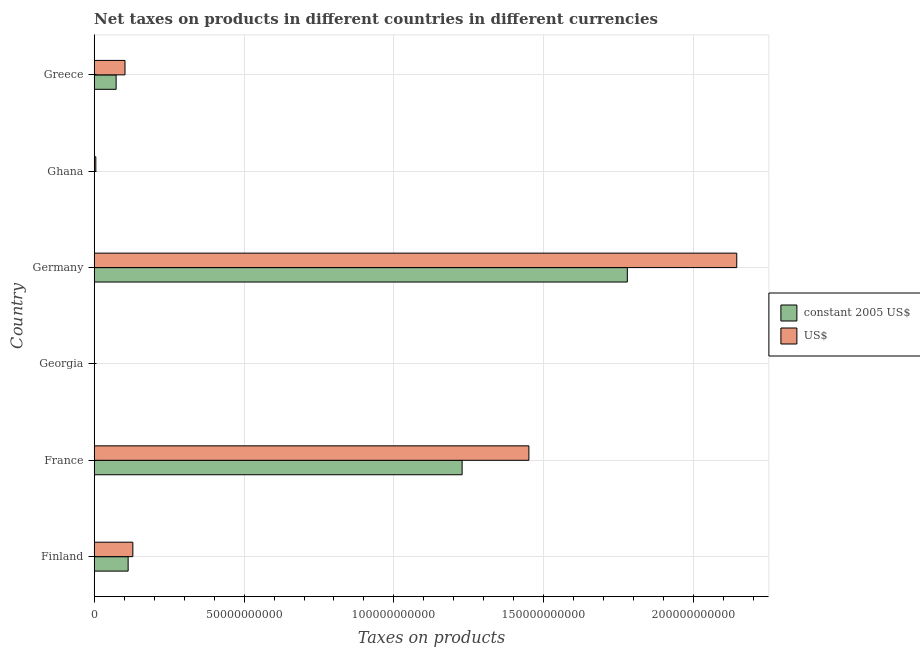How many groups of bars are there?
Offer a very short reply. 6. Are the number of bars per tick equal to the number of legend labels?
Keep it short and to the point. Yes. Are the number of bars on each tick of the Y-axis equal?
Give a very brief answer. Yes. How many bars are there on the 3rd tick from the bottom?
Provide a short and direct response. 2. What is the label of the 5th group of bars from the top?
Give a very brief answer. France. In how many cases, is the number of bars for a given country not equal to the number of legend labels?
Offer a very short reply. 0. What is the net taxes in us$ in Greece?
Your answer should be very brief. 1.03e+1. Across all countries, what is the maximum net taxes in us$?
Give a very brief answer. 2.14e+11. Across all countries, what is the minimum net taxes in us$?
Your answer should be compact. 5.30e+07. In which country was the net taxes in constant 2005 us$ minimum?
Give a very brief answer. Georgia. What is the total net taxes in us$ in the graph?
Your response must be concise. 3.83e+11. What is the difference between the net taxes in us$ in Ghana and that in Greece?
Keep it short and to the point. -9.73e+09. What is the difference between the net taxes in constant 2005 us$ in Finland and the net taxes in us$ in France?
Provide a short and direct response. -1.34e+11. What is the average net taxes in constant 2005 us$ per country?
Offer a terse response. 5.32e+1. What is the difference between the net taxes in us$ and net taxes in constant 2005 us$ in Germany?
Keep it short and to the point. 3.65e+1. What is the ratio of the net taxes in constant 2005 us$ in Finland to that in France?
Give a very brief answer. 0.09. Is the difference between the net taxes in constant 2005 us$ in Georgia and Greece greater than the difference between the net taxes in us$ in Georgia and Greece?
Keep it short and to the point. Yes. What is the difference between the highest and the second highest net taxes in us$?
Offer a terse response. 6.94e+1. What is the difference between the highest and the lowest net taxes in constant 2005 us$?
Give a very brief answer. 1.78e+11. What does the 1st bar from the top in France represents?
Your answer should be compact. US$. What does the 2nd bar from the bottom in Georgia represents?
Keep it short and to the point. US$. How many bars are there?
Your response must be concise. 12. Are the values on the major ticks of X-axis written in scientific E-notation?
Your answer should be compact. No. Does the graph contain grids?
Provide a succinct answer. Yes. Where does the legend appear in the graph?
Keep it short and to the point. Center right. How many legend labels are there?
Your response must be concise. 2. What is the title of the graph?
Keep it short and to the point. Net taxes on products in different countries in different currencies. Does "Foreign Liabilities" appear as one of the legend labels in the graph?
Keep it short and to the point. No. What is the label or title of the X-axis?
Your answer should be very brief. Taxes on products. What is the Taxes on products of constant 2005 US$ in Finland?
Keep it short and to the point. 1.13e+1. What is the Taxes on products of US$ in Finland?
Provide a short and direct response. 1.29e+1. What is the Taxes on products in constant 2005 US$ in France?
Offer a very short reply. 1.23e+11. What is the Taxes on products in US$ in France?
Provide a succinct answer. 1.45e+11. What is the Taxes on products of constant 2005 US$ in Georgia?
Make the answer very short. 1.90e+07. What is the Taxes on products in US$ in Georgia?
Give a very brief answer. 5.30e+07. What is the Taxes on products in constant 2005 US$ in Germany?
Give a very brief answer. 1.78e+11. What is the Taxes on products of US$ in Germany?
Your response must be concise. 2.14e+11. What is the Taxes on products in constant 2005 US$ in Ghana?
Give a very brief answer. 5.19e+07. What is the Taxes on products of US$ in Ghana?
Provide a succinct answer. 5.43e+08. What is the Taxes on products in constant 2005 US$ in Greece?
Your response must be concise. 7.32e+09. What is the Taxes on products of US$ in Greece?
Your response must be concise. 1.03e+1. Across all countries, what is the maximum Taxes on products in constant 2005 US$?
Make the answer very short. 1.78e+11. Across all countries, what is the maximum Taxes on products of US$?
Keep it short and to the point. 2.14e+11. Across all countries, what is the minimum Taxes on products in constant 2005 US$?
Make the answer very short. 1.90e+07. Across all countries, what is the minimum Taxes on products in US$?
Your answer should be compact. 5.30e+07. What is the total Taxes on products in constant 2005 US$ in the graph?
Provide a short and direct response. 3.19e+11. What is the total Taxes on products in US$ in the graph?
Give a very brief answer. 3.83e+11. What is the difference between the Taxes on products of constant 2005 US$ in Finland and that in France?
Offer a very short reply. -1.11e+11. What is the difference between the Taxes on products in US$ in Finland and that in France?
Provide a short and direct response. -1.32e+11. What is the difference between the Taxes on products in constant 2005 US$ in Finland and that in Georgia?
Make the answer very short. 1.13e+1. What is the difference between the Taxes on products of US$ in Finland and that in Georgia?
Your answer should be compact. 1.28e+1. What is the difference between the Taxes on products in constant 2005 US$ in Finland and that in Germany?
Offer a very short reply. -1.67e+11. What is the difference between the Taxes on products of US$ in Finland and that in Germany?
Make the answer very short. -2.01e+11. What is the difference between the Taxes on products of constant 2005 US$ in Finland and that in Ghana?
Make the answer very short. 1.13e+1. What is the difference between the Taxes on products in US$ in Finland and that in Ghana?
Provide a succinct answer. 1.23e+1. What is the difference between the Taxes on products in constant 2005 US$ in Finland and that in Greece?
Provide a short and direct response. 4.01e+09. What is the difference between the Taxes on products of US$ in Finland and that in Greece?
Ensure brevity in your answer.  2.62e+09. What is the difference between the Taxes on products of constant 2005 US$ in France and that in Georgia?
Provide a short and direct response. 1.23e+11. What is the difference between the Taxes on products of US$ in France and that in Georgia?
Offer a terse response. 1.45e+11. What is the difference between the Taxes on products of constant 2005 US$ in France and that in Germany?
Offer a terse response. -5.51e+1. What is the difference between the Taxes on products of US$ in France and that in Germany?
Offer a terse response. -6.94e+1. What is the difference between the Taxes on products of constant 2005 US$ in France and that in Ghana?
Your answer should be very brief. 1.23e+11. What is the difference between the Taxes on products in US$ in France and that in Ghana?
Your response must be concise. 1.44e+11. What is the difference between the Taxes on products of constant 2005 US$ in France and that in Greece?
Your answer should be very brief. 1.15e+11. What is the difference between the Taxes on products in US$ in France and that in Greece?
Your answer should be compact. 1.35e+11. What is the difference between the Taxes on products of constant 2005 US$ in Georgia and that in Germany?
Provide a short and direct response. -1.78e+11. What is the difference between the Taxes on products of US$ in Georgia and that in Germany?
Provide a short and direct response. -2.14e+11. What is the difference between the Taxes on products of constant 2005 US$ in Georgia and that in Ghana?
Keep it short and to the point. -3.29e+07. What is the difference between the Taxes on products in US$ in Georgia and that in Ghana?
Offer a very short reply. -4.90e+08. What is the difference between the Taxes on products of constant 2005 US$ in Georgia and that in Greece?
Ensure brevity in your answer.  -7.30e+09. What is the difference between the Taxes on products of US$ in Georgia and that in Greece?
Offer a very short reply. -1.02e+1. What is the difference between the Taxes on products of constant 2005 US$ in Germany and that in Ghana?
Provide a succinct answer. 1.78e+11. What is the difference between the Taxes on products of US$ in Germany and that in Ghana?
Your answer should be compact. 2.14e+11. What is the difference between the Taxes on products in constant 2005 US$ in Germany and that in Greece?
Make the answer very short. 1.71e+11. What is the difference between the Taxes on products in US$ in Germany and that in Greece?
Make the answer very short. 2.04e+11. What is the difference between the Taxes on products in constant 2005 US$ in Ghana and that in Greece?
Ensure brevity in your answer.  -7.27e+09. What is the difference between the Taxes on products of US$ in Ghana and that in Greece?
Provide a short and direct response. -9.73e+09. What is the difference between the Taxes on products of constant 2005 US$ in Finland and the Taxes on products of US$ in France?
Make the answer very short. -1.34e+11. What is the difference between the Taxes on products of constant 2005 US$ in Finland and the Taxes on products of US$ in Georgia?
Provide a succinct answer. 1.13e+1. What is the difference between the Taxes on products in constant 2005 US$ in Finland and the Taxes on products in US$ in Germany?
Your answer should be compact. -2.03e+11. What is the difference between the Taxes on products in constant 2005 US$ in Finland and the Taxes on products in US$ in Ghana?
Your answer should be compact. 1.08e+1. What is the difference between the Taxes on products of constant 2005 US$ in Finland and the Taxes on products of US$ in Greece?
Your response must be concise. 1.05e+09. What is the difference between the Taxes on products in constant 2005 US$ in France and the Taxes on products in US$ in Georgia?
Make the answer very short. 1.23e+11. What is the difference between the Taxes on products in constant 2005 US$ in France and the Taxes on products in US$ in Germany?
Provide a short and direct response. -9.16e+1. What is the difference between the Taxes on products of constant 2005 US$ in France and the Taxes on products of US$ in Ghana?
Provide a succinct answer. 1.22e+11. What is the difference between the Taxes on products in constant 2005 US$ in France and the Taxes on products in US$ in Greece?
Your answer should be compact. 1.12e+11. What is the difference between the Taxes on products of constant 2005 US$ in Georgia and the Taxes on products of US$ in Germany?
Your answer should be compact. -2.14e+11. What is the difference between the Taxes on products in constant 2005 US$ in Georgia and the Taxes on products in US$ in Ghana?
Provide a short and direct response. -5.24e+08. What is the difference between the Taxes on products in constant 2005 US$ in Georgia and the Taxes on products in US$ in Greece?
Ensure brevity in your answer.  -1.03e+1. What is the difference between the Taxes on products of constant 2005 US$ in Germany and the Taxes on products of US$ in Ghana?
Ensure brevity in your answer.  1.77e+11. What is the difference between the Taxes on products in constant 2005 US$ in Germany and the Taxes on products in US$ in Greece?
Offer a terse response. 1.68e+11. What is the difference between the Taxes on products in constant 2005 US$ in Ghana and the Taxes on products in US$ in Greece?
Provide a succinct answer. -1.02e+1. What is the average Taxes on products of constant 2005 US$ per country?
Offer a terse response. 5.32e+1. What is the average Taxes on products in US$ per country?
Provide a succinct answer. 6.39e+1. What is the difference between the Taxes on products in constant 2005 US$ and Taxes on products in US$ in Finland?
Ensure brevity in your answer.  -1.57e+09. What is the difference between the Taxes on products in constant 2005 US$ and Taxes on products in US$ in France?
Provide a succinct answer. -2.23e+1. What is the difference between the Taxes on products in constant 2005 US$ and Taxes on products in US$ in Georgia?
Make the answer very short. -3.40e+07. What is the difference between the Taxes on products of constant 2005 US$ and Taxes on products of US$ in Germany?
Your response must be concise. -3.65e+1. What is the difference between the Taxes on products in constant 2005 US$ and Taxes on products in US$ in Ghana?
Your answer should be compact. -4.91e+08. What is the difference between the Taxes on products in constant 2005 US$ and Taxes on products in US$ in Greece?
Your answer should be very brief. -2.96e+09. What is the ratio of the Taxes on products of constant 2005 US$ in Finland to that in France?
Give a very brief answer. 0.09. What is the ratio of the Taxes on products in US$ in Finland to that in France?
Your answer should be very brief. 0.09. What is the ratio of the Taxes on products in constant 2005 US$ in Finland to that in Georgia?
Provide a short and direct response. 595.24. What is the ratio of the Taxes on products of US$ in Finland to that in Georgia?
Offer a very short reply. 243.2. What is the ratio of the Taxes on products in constant 2005 US$ in Finland to that in Germany?
Provide a short and direct response. 0.06. What is the ratio of the Taxes on products in US$ in Finland to that in Germany?
Your response must be concise. 0.06. What is the ratio of the Taxes on products in constant 2005 US$ in Finland to that in Ghana?
Provide a succinct answer. 218.14. What is the ratio of the Taxes on products in US$ in Finland to that in Ghana?
Provide a short and direct response. 23.74. What is the ratio of the Taxes on products in constant 2005 US$ in Finland to that in Greece?
Ensure brevity in your answer.  1.55. What is the ratio of the Taxes on products in US$ in Finland to that in Greece?
Your response must be concise. 1.25. What is the ratio of the Taxes on products of constant 2005 US$ in France to that in Georgia?
Your response must be concise. 6451.63. What is the ratio of the Taxes on products of US$ in France to that in Georgia?
Your answer should be compact. 2735.91. What is the ratio of the Taxes on products of constant 2005 US$ in France to that in Germany?
Give a very brief answer. 0.69. What is the ratio of the Taxes on products of US$ in France to that in Germany?
Your response must be concise. 0.68. What is the ratio of the Taxes on products in constant 2005 US$ in France to that in Ghana?
Your answer should be very brief. 2364.39. What is the ratio of the Taxes on products of US$ in France to that in Ghana?
Provide a succinct answer. 267.06. What is the ratio of the Taxes on products of constant 2005 US$ in France to that in Greece?
Give a very brief answer. 16.78. What is the ratio of the Taxes on products of US$ in France to that in Greece?
Your response must be concise. 14.11. What is the ratio of the Taxes on products in constant 2005 US$ in Georgia to that in Germany?
Your answer should be compact. 0. What is the ratio of the Taxes on products of constant 2005 US$ in Georgia to that in Ghana?
Provide a short and direct response. 0.37. What is the ratio of the Taxes on products in US$ in Georgia to that in Ghana?
Give a very brief answer. 0.1. What is the ratio of the Taxes on products in constant 2005 US$ in Georgia to that in Greece?
Give a very brief answer. 0. What is the ratio of the Taxes on products of US$ in Georgia to that in Greece?
Your response must be concise. 0.01. What is the ratio of the Taxes on products of constant 2005 US$ in Germany to that in Ghana?
Your answer should be very brief. 3426.02. What is the ratio of the Taxes on products in US$ in Germany to that in Ghana?
Ensure brevity in your answer.  394.75. What is the ratio of the Taxes on products of constant 2005 US$ in Germany to that in Greece?
Your answer should be compact. 24.31. What is the ratio of the Taxes on products in US$ in Germany to that in Greece?
Keep it short and to the point. 20.86. What is the ratio of the Taxes on products of constant 2005 US$ in Ghana to that in Greece?
Give a very brief answer. 0.01. What is the ratio of the Taxes on products in US$ in Ghana to that in Greece?
Your answer should be compact. 0.05. What is the difference between the highest and the second highest Taxes on products of constant 2005 US$?
Provide a succinct answer. 5.51e+1. What is the difference between the highest and the second highest Taxes on products of US$?
Provide a succinct answer. 6.94e+1. What is the difference between the highest and the lowest Taxes on products of constant 2005 US$?
Your answer should be very brief. 1.78e+11. What is the difference between the highest and the lowest Taxes on products of US$?
Your answer should be very brief. 2.14e+11. 